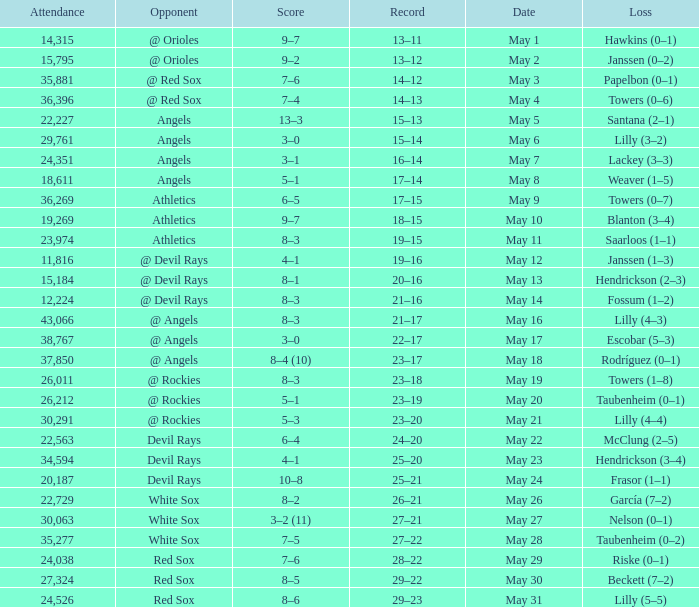When the team had their record of 16–14, what was the total attendance? 1.0. 